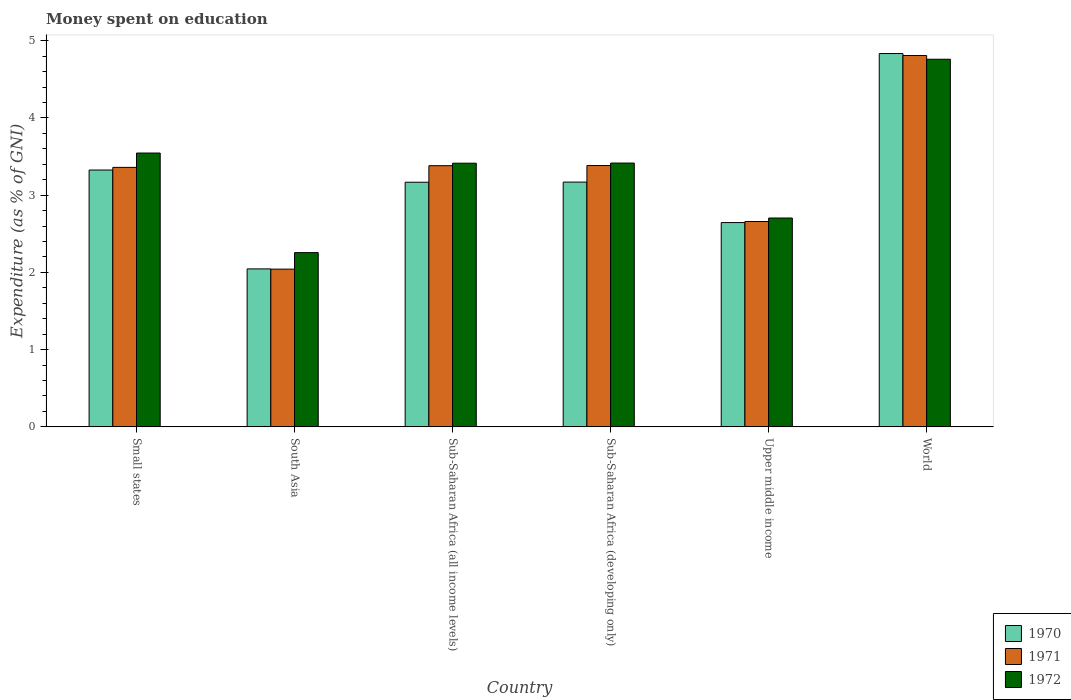How many groups of bars are there?
Offer a very short reply. 6. Are the number of bars on each tick of the X-axis equal?
Offer a terse response. Yes. How many bars are there on the 1st tick from the left?
Keep it short and to the point. 3. What is the label of the 1st group of bars from the left?
Your response must be concise. Small states. What is the amount of money spent on education in 1971 in Sub-Saharan Africa (all income levels)?
Offer a terse response. 3.38. Across all countries, what is the maximum amount of money spent on education in 1972?
Offer a very short reply. 4.76. Across all countries, what is the minimum amount of money spent on education in 1970?
Your answer should be compact. 2.05. In which country was the amount of money spent on education in 1971 maximum?
Give a very brief answer. World. In which country was the amount of money spent on education in 1970 minimum?
Offer a very short reply. South Asia. What is the total amount of money spent on education in 1970 in the graph?
Your answer should be compact. 19.19. What is the difference between the amount of money spent on education in 1972 in Small states and that in South Asia?
Your answer should be compact. 1.29. What is the difference between the amount of money spent on education in 1972 in South Asia and the amount of money spent on education in 1970 in World?
Provide a short and direct response. -2.58. What is the average amount of money spent on education in 1970 per country?
Keep it short and to the point. 3.2. What is the difference between the amount of money spent on education of/in 1970 and amount of money spent on education of/in 1971 in Upper middle income?
Provide a short and direct response. -0.01. What is the ratio of the amount of money spent on education in 1972 in Sub-Saharan Africa (developing only) to that in Upper middle income?
Provide a short and direct response. 1.26. Is the amount of money spent on education in 1971 in South Asia less than that in Sub-Saharan Africa (developing only)?
Ensure brevity in your answer.  Yes. What is the difference between the highest and the second highest amount of money spent on education in 1971?
Offer a very short reply. -0. What is the difference between the highest and the lowest amount of money spent on education in 1970?
Your answer should be compact. 2.79. In how many countries, is the amount of money spent on education in 1971 greater than the average amount of money spent on education in 1971 taken over all countries?
Your response must be concise. 4. Is the sum of the amount of money spent on education in 1970 in Sub-Saharan Africa (developing only) and Upper middle income greater than the maximum amount of money spent on education in 1971 across all countries?
Provide a short and direct response. Yes. What does the 3rd bar from the left in World represents?
Provide a short and direct response. 1972. What does the 2nd bar from the right in Upper middle income represents?
Offer a terse response. 1971. Is it the case that in every country, the sum of the amount of money spent on education in 1970 and amount of money spent on education in 1972 is greater than the amount of money spent on education in 1971?
Keep it short and to the point. Yes. How many bars are there?
Provide a succinct answer. 18. Are all the bars in the graph horizontal?
Your response must be concise. No. What is the difference between two consecutive major ticks on the Y-axis?
Your answer should be compact. 1. Are the values on the major ticks of Y-axis written in scientific E-notation?
Offer a terse response. No. Does the graph contain any zero values?
Offer a terse response. No. Where does the legend appear in the graph?
Offer a very short reply. Bottom right. How many legend labels are there?
Offer a very short reply. 3. What is the title of the graph?
Provide a short and direct response. Money spent on education. What is the label or title of the Y-axis?
Ensure brevity in your answer.  Expenditure (as % of GNI). What is the Expenditure (as % of GNI) of 1970 in Small states?
Give a very brief answer. 3.33. What is the Expenditure (as % of GNI) of 1971 in Small states?
Offer a very short reply. 3.36. What is the Expenditure (as % of GNI) of 1972 in Small states?
Your response must be concise. 3.55. What is the Expenditure (as % of GNI) of 1970 in South Asia?
Make the answer very short. 2.05. What is the Expenditure (as % of GNI) in 1971 in South Asia?
Provide a short and direct response. 2.04. What is the Expenditure (as % of GNI) of 1972 in South Asia?
Give a very brief answer. 2.26. What is the Expenditure (as % of GNI) in 1970 in Sub-Saharan Africa (all income levels)?
Keep it short and to the point. 3.17. What is the Expenditure (as % of GNI) in 1971 in Sub-Saharan Africa (all income levels)?
Your response must be concise. 3.38. What is the Expenditure (as % of GNI) in 1972 in Sub-Saharan Africa (all income levels)?
Ensure brevity in your answer.  3.41. What is the Expenditure (as % of GNI) of 1970 in Sub-Saharan Africa (developing only)?
Provide a succinct answer. 3.17. What is the Expenditure (as % of GNI) in 1971 in Sub-Saharan Africa (developing only)?
Your answer should be compact. 3.38. What is the Expenditure (as % of GNI) of 1972 in Sub-Saharan Africa (developing only)?
Your response must be concise. 3.42. What is the Expenditure (as % of GNI) in 1970 in Upper middle income?
Provide a short and direct response. 2.65. What is the Expenditure (as % of GNI) in 1971 in Upper middle income?
Offer a terse response. 2.66. What is the Expenditure (as % of GNI) in 1972 in Upper middle income?
Keep it short and to the point. 2.7. What is the Expenditure (as % of GNI) in 1970 in World?
Your answer should be very brief. 4.83. What is the Expenditure (as % of GNI) in 1971 in World?
Provide a short and direct response. 4.81. What is the Expenditure (as % of GNI) of 1972 in World?
Offer a very short reply. 4.76. Across all countries, what is the maximum Expenditure (as % of GNI) in 1970?
Give a very brief answer. 4.83. Across all countries, what is the maximum Expenditure (as % of GNI) of 1971?
Give a very brief answer. 4.81. Across all countries, what is the maximum Expenditure (as % of GNI) in 1972?
Provide a short and direct response. 4.76. Across all countries, what is the minimum Expenditure (as % of GNI) of 1970?
Keep it short and to the point. 2.05. Across all countries, what is the minimum Expenditure (as % of GNI) in 1971?
Provide a succinct answer. 2.04. Across all countries, what is the minimum Expenditure (as % of GNI) in 1972?
Ensure brevity in your answer.  2.26. What is the total Expenditure (as % of GNI) in 1970 in the graph?
Keep it short and to the point. 19.19. What is the total Expenditure (as % of GNI) in 1971 in the graph?
Keep it short and to the point. 19.64. What is the total Expenditure (as % of GNI) in 1972 in the graph?
Give a very brief answer. 20.1. What is the difference between the Expenditure (as % of GNI) in 1970 in Small states and that in South Asia?
Ensure brevity in your answer.  1.28. What is the difference between the Expenditure (as % of GNI) of 1971 in Small states and that in South Asia?
Make the answer very short. 1.32. What is the difference between the Expenditure (as % of GNI) of 1972 in Small states and that in South Asia?
Provide a succinct answer. 1.29. What is the difference between the Expenditure (as % of GNI) of 1970 in Small states and that in Sub-Saharan Africa (all income levels)?
Offer a very short reply. 0.16. What is the difference between the Expenditure (as % of GNI) of 1971 in Small states and that in Sub-Saharan Africa (all income levels)?
Your answer should be very brief. -0.02. What is the difference between the Expenditure (as % of GNI) of 1972 in Small states and that in Sub-Saharan Africa (all income levels)?
Provide a short and direct response. 0.13. What is the difference between the Expenditure (as % of GNI) in 1970 in Small states and that in Sub-Saharan Africa (developing only)?
Make the answer very short. 0.16. What is the difference between the Expenditure (as % of GNI) of 1971 in Small states and that in Sub-Saharan Africa (developing only)?
Provide a short and direct response. -0.02. What is the difference between the Expenditure (as % of GNI) of 1972 in Small states and that in Sub-Saharan Africa (developing only)?
Ensure brevity in your answer.  0.13. What is the difference between the Expenditure (as % of GNI) of 1970 in Small states and that in Upper middle income?
Provide a short and direct response. 0.68. What is the difference between the Expenditure (as % of GNI) of 1971 in Small states and that in Upper middle income?
Your answer should be compact. 0.7. What is the difference between the Expenditure (as % of GNI) in 1972 in Small states and that in Upper middle income?
Provide a succinct answer. 0.84. What is the difference between the Expenditure (as % of GNI) of 1970 in Small states and that in World?
Provide a succinct answer. -1.51. What is the difference between the Expenditure (as % of GNI) of 1971 in Small states and that in World?
Provide a short and direct response. -1.45. What is the difference between the Expenditure (as % of GNI) in 1972 in Small states and that in World?
Make the answer very short. -1.21. What is the difference between the Expenditure (as % of GNI) in 1970 in South Asia and that in Sub-Saharan Africa (all income levels)?
Your answer should be very brief. -1.12. What is the difference between the Expenditure (as % of GNI) of 1971 in South Asia and that in Sub-Saharan Africa (all income levels)?
Provide a short and direct response. -1.34. What is the difference between the Expenditure (as % of GNI) in 1972 in South Asia and that in Sub-Saharan Africa (all income levels)?
Keep it short and to the point. -1.16. What is the difference between the Expenditure (as % of GNI) in 1970 in South Asia and that in Sub-Saharan Africa (developing only)?
Give a very brief answer. -1.12. What is the difference between the Expenditure (as % of GNI) of 1971 in South Asia and that in Sub-Saharan Africa (developing only)?
Keep it short and to the point. -1.34. What is the difference between the Expenditure (as % of GNI) in 1972 in South Asia and that in Sub-Saharan Africa (developing only)?
Ensure brevity in your answer.  -1.16. What is the difference between the Expenditure (as % of GNI) of 1970 in South Asia and that in Upper middle income?
Your answer should be very brief. -0.6. What is the difference between the Expenditure (as % of GNI) in 1971 in South Asia and that in Upper middle income?
Keep it short and to the point. -0.62. What is the difference between the Expenditure (as % of GNI) in 1972 in South Asia and that in Upper middle income?
Provide a short and direct response. -0.45. What is the difference between the Expenditure (as % of GNI) in 1970 in South Asia and that in World?
Give a very brief answer. -2.79. What is the difference between the Expenditure (as % of GNI) in 1971 in South Asia and that in World?
Provide a succinct answer. -2.77. What is the difference between the Expenditure (as % of GNI) of 1972 in South Asia and that in World?
Ensure brevity in your answer.  -2.5. What is the difference between the Expenditure (as % of GNI) in 1970 in Sub-Saharan Africa (all income levels) and that in Sub-Saharan Africa (developing only)?
Your answer should be very brief. -0. What is the difference between the Expenditure (as % of GNI) of 1971 in Sub-Saharan Africa (all income levels) and that in Sub-Saharan Africa (developing only)?
Your response must be concise. -0. What is the difference between the Expenditure (as % of GNI) in 1972 in Sub-Saharan Africa (all income levels) and that in Sub-Saharan Africa (developing only)?
Provide a succinct answer. -0. What is the difference between the Expenditure (as % of GNI) of 1970 in Sub-Saharan Africa (all income levels) and that in Upper middle income?
Provide a succinct answer. 0.52. What is the difference between the Expenditure (as % of GNI) in 1971 in Sub-Saharan Africa (all income levels) and that in Upper middle income?
Offer a terse response. 0.72. What is the difference between the Expenditure (as % of GNI) in 1972 in Sub-Saharan Africa (all income levels) and that in Upper middle income?
Offer a terse response. 0.71. What is the difference between the Expenditure (as % of GNI) of 1970 in Sub-Saharan Africa (all income levels) and that in World?
Keep it short and to the point. -1.67. What is the difference between the Expenditure (as % of GNI) of 1971 in Sub-Saharan Africa (all income levels) and that in World?
Your answer should be compact. -1.43. What is the difference between the Expenditure (as % of GNI) in 1972 in Sub-Saharan Africa (all income levels) and that in World?
Provide a short and direct response. -1.35. What is the difference between the Expenditure (as % of GNI) in 1970 in Sub-Saharan Africa (developing only) and that in Upper middle income?
Provide a succinct answer. 0.52. What is the difference between the Expenditure (as % of GNI) in 1971 in Sub-Saharan Africa (developing only) and that in Upper middle income?
Keep it short and to the point. 0.72. What is the difference between the Expenditure (as % of GNI) in 1972 in Sub-Saharan Africa (developing only) and that in Upper middle income?
Provide a succinct answer. 0.71. What is the difference between the Expenditure (as % of GNI) in 1970 in Sub-Saharan Africa (developing only) and that in World?
Ensure brevity in your answer.  -1.66. What is the difference between the Expenditure (as % of GNI) of 1971 in Sub-Saharan Africa (developing only) and that in World?
Provide a succinct answer. -1.42. What is the difference between the Expenditure (as % of GNI) of 1972 in Sub-Saharan Africa (developing only) and that in World?
Keep it short and to the point. -1.34. What is the difference between the Expenditure (as % of GNI) of 1970 in Upper middle income and that in World?
Give a very brief answer. -2.19. What is the difference between the Expenditure (as % of GNI) in 1971 in Upper middle income and that in World?
Offer a terse response. -2.15. What is the difference between the Expenditure (as % of GNI) of 1972 in Upper middle income and that in World?
Give a very brief answer. -2.06. What is the difference between the Expenditure (as % of GNI) of 1970 in Small states and the Expenditure (as % of GNI) of 1971 in South Asia?
Make the answer very short. 1.28. What is the difference between the Expenditure (as % of GNI) of 1970 in Small states and the Expenditure (as % of GNI) of 1972 in South Asia?
Your answer should be very brief. 1.07. What is the difference between the Expenditure (as % of GNI) of 1971 in Small states and the Expenditure (as % of GNI) of 1972 in South Asia?
Keep it short and to the point. 1.1. What is the difference between the Expenditure (as % of GNI) in 1970 in Small states and the Expenditure (as % of GNI) in 1971 in Sub-Saharan Africa (all income levels)?
Your answer should be very brief. -0.06. What is the difference between the Expenditure (as % of GNI) of 1970 in Small states and the Expenditure (as % of GNI) of 1972 in Sub-Saharan Africa (all income levels)?
Give a very brief answer. -0.09. What is the difference between the Expenditure (as % of GNI) of 1971 in Small states and the Expenditure (as % of GNI) of 1972 in Sub-Saharan Africa (all income levels)?
Offer a very short reply. -0.05. What is the difference between the Expenditure (as % of GNI) in 1970 in Small states and the Expenditure (as % of GNI) in 1971 in Sub-Saharan Africa (developing only)?
Provide a succinct answer. -0.06. What is the difference between the Expenditure (as % of GNI) in 1970 in Small states and the Expenditure (as % of GNI) in 1972 in Sub-Saharan Africa (developing only)?
Offer a very short reply. -0.09. What is the difference between the Expenditure (as % of GNI) of 1971 in Small states and the Expenditure (as % of GNI) of 1972 in Sub-Saharan Africa (developing only)?
Ensure brevity in your answer.  -0.06. What is the difference between the Expenditure (as % of GNI) in 1970 in Small states and the Expenditure (as % of GNI) in 1971 in Upper middle income?
Give a very brief answer. 0.67. What is the difference between the Expenditure (as % of GNI) of 1970 in Small states and the Expenditure (as % of GNI) of 1972 in Upper middle income?
Your response must be concise. 0.62. What is the difference between the Expenditure (as % of GNI) of 1971 in Small states and the Expenditure (as % of GNI) of 1972 in Upper middle income?
Your response must be concise. 0.66. What is the difference between the Expenditure (as % of GNI) in 1970 in Small states and the Expenditure (as % of GNI) in 1971 in World?
Offer a very short reply. -1.48. What is the difference between the Expenditure (as % of GNI) of 1970 in Small states and the Expenditure (as % of GNI) of 1972 in World?
Your response must be concise. -1.43. What is the difference between the Expenditure (as % of GNI) of 1971 in Small states and the Expenditure (as % of GNI) of 1972 in World?
Keep it short and to the point. -1.4. What is the difference between the Expenditure (as % of GNI) of 1970 in South Asia and the Expenditure (as % of GNI) of 1971 in Sub-Saharan Africa (all income levels)?
Make the answer very short. -1.34. What is the difference between the Expenditure (as % of GNI) of 1970 in South Asia and the Expenditure (as % of GNI) of 1972 in Sub-Saharan Africa (all income levels)?
Provide a succinct answer. -1.37. What is the difference between the Expenditure (as % of GNI) of 1971 in South Asia and the Expenditure (as % of GNI) of 1972 in Sub-Saharan Africa (all income levels)?
Ensure brevity in your answer.  -1.37. What is the difference between the Expenditure (as % of GNI) in 1970 in South Asia and the Expenditure (as % of GNI) in 1971 in Sub-Saharan Africa (developing only)?
Ensure brevity in your answer.  -1.34. What is the difference between the Expenditure (as % of GNI) in 1970 in South Asia and the Expenditure (as % of GNI) in 1972 in Sub-Saharan Africa (developing only)?
Your answer should be very brief. -1.37. What is the difference between the Expenditure (as % of GNI) in 1971 in South Asia and the Expenditure (as % of GNI) in 1972 in Sub-Saharan Africa (developing only)?
Your response must be concise. -1.37. What is the difference between the Expenditure (as % of GNI) in 1970 in South Asia and the Expenditure (as % of GNI) in 1971 in Upper middle income?
Make the answer very short. -0.61. What is the difference between the Expenditure (as % of GNI) in 1970 in South Asia and the Expenditure (as % of GNI) in 1972 in Upper middle income?
Provide a succinct answer. -0.66. What is the difference between the Expenditure (as % of GNI) in 1971 in South Asia and the Expenditure (as % of GNI) in 1972 in Upper middle income?
Keep it short and to the point. -0.66. What is the difference between the Expenditure (as % of GNI) in 1970 in South Asia and the Expenditure (as % of GNI) in 1971 in World?
Your answer should be very brief. -2.76. What is the difference between the Expenditure (as % of GNI) of 1970 in South Asia and the Expenditure (as % of GNI) of 1972 in World?
Your answer should be very brief. -2.71. What is the difference between the Expenditure (as % of GNI) of 1971 in South Asia and the Expenditure (as % of GNI) of 1972 in World?
Your answer should be very brief. -2.72. What is the difference between the Expenditure (as % of GNI) in 1970 in Sub-Saharan Africa (all income levels) and the Expenditure (as % of GNI) in 1971 in Sub-Saharan Africa (developing only)?
Make the answer very short. -0.22. What is the difference between the Expenditure (as % of GNI) of 1970 in Sub-Saharan Africa (all income levels) and the Expenditure (as % of GNI) of 1972 in Sub-Saharan Africa (developing only)?
Ensure brevity in your answer.  -0.25. What is the difference between the Expenditure (as % of GNI) in 1971 in Sub-Saharan Africa (all income levels) and the Expenditure (as % of GNI) in 1972 in Sub-Saharan Africa (developing only)?
Ensure brevity in your answer.  -0.03. What is the difference between the Expenditure (as % of GNI) of 1970 in Sub-Saharan Africa (all income levels) and the Expenditure (as % of GNI) of 1971 in Upper middle income?
Offer a very short reply. 0.51. What is the difference between the Expenditure (as % of GNI) of 1970 in Sub-Saharan Africa (all income levels) and the Expenditure (as % of GNI) of 1972 in Upper middle income?
Provide a short and direct response. 0.46. What is the difference between the Expenditure (as % of GNI) of 1971 in Sub-Saharan Africa (all income levels) and the Expenditure (as % of GNI) of 1972 in Upper middle income?
Ensure brevity in your answer.  0.68. What is the difference between the Expenditure (as % of GNI) in 1970 in Sub-Saharan Africa (all income levels) and the Expenditure (as % of GNI) in 1971 in World?
Offer a terse response. -1.64. What is the difference between the Expenditure (as % of GNI) in 1970 in Sub-Saharan Africa (all income levels) and the Expenditure (as % of GNI) in 1972 in World?
Give a very brief answer. -1.59. What is the difference between the Expenditure (as % of GNI) of 1971 in Sub-Saharan Africa (all income levels) and the Expenditure (as % of GNI) of 1972 in World?
Offer a terse response. -1.38. What is the difference between the Expenditure (as % of GNI) in 1970 in Sub-Saharan Africa (developing only) and the Expenditure (as % of GNI) in 1971 in Upper middle income?
Ensure brevity in your answer.  0.51. What is the difference between the Expenditure (as % of GNI) of 1970 in Sub-Saharan Africa (developing only) and the Expenditure (as % of GNI) of 1972 in Upper middle income?
Provide a succinct answer. 0.47. What is the difference between the Expenditure (as % of GNI) of 1971 in Sub-Saharan Africa (developing only) and the Expenditure (as % of GNI) of 1972 in Upper middle income?
Make the answer very short. 0.68. What is the difference between the Expenditure (as % of GNI) in 1970 in Sub-Saharan Africa (developing only) and the Expenditure (as % of GNI) in 1971 in World?
Provide a succinct answer. -1.64. What is the difference between the Expenditure (as % of GNI) of 1970 in Sub-Saharan Africa (developing only) and the Expenditure (as % of GNI) of 1972 in World?
Offer a very short reply. -1.59. What is the difference between the Expenditure (as % of GNI) in 1971 in Sub-Saharan Africa (developing only) and the Expenditure (as % of GNI) in 1972 in World?
Give a very brief answer. -1.38. What is the difference between the Expenditure (as % of GNI) in 1970 in Upper middle income and the Expenditure (as % of GNI) in 1971 in World?
Provide a short and direct response. -2.16. What is the difference between the Expenditure (as % of GNI) in 1970 in Upper middle income and the Expenditure (as % of GNI) in 1972 in World?
Your answer should be very brief. -2.12. What is the difference between the Expenditure (as % of GNI) in 1971 in Upper middle income and the Expenditure (as % of GNI) in 1972 in World?
Your answer should be very brief. -2.1. What is the average Expenditure (as % of GNI) of 1970 per country?
Provide a succinct answer. 3.2. What is the average Expenditure (as % of GNI) of 1971 per country?
Provide a short and direct response. 3.27. What is the average Expenditure (as % of GNI) in 1972 per country?
Give a very brief answer. 3.35. What is the difference between the Expenditure (as % of GNI) in 1970 and Expenditure (as % of GNI) in 1971 in Small states?
Provide a succinct answer. -0.03. What is the difference between the Expenditure (as % of GNI) of 1970 and Expenditure (as % of GNI) of 1972 in Small states?
Provide a succinct answer. -0.22. What is the difference between the Expenditure (as % of GNI) of 1971 and Expenditure (as % of GNI) of 1972 in Small states?
Your answer should be very brief. -0.19. What is the difference between the Expenditure (as % of GNI) of 1970 and Expenditure (as % of GNI) of 1971 in South Asia?
Make the answer very short. 0. What is the difference between the Expenditure (as % of GNI) of 1970 and Expenditure (as % of GNI) of 1972 in South Asia?
Your response must be concise. -0.21. What is the difference between the Expenditure (as % of GNI) of 1971 and Expenditure (as % of GNI) of 1972 in South Asia?
Your answer should be compact. -0.21. What is the difference between the Expenditure (as % of GNI) of 1970 and Expenditure (as % of GNI) of 1971 in Sub-Saharan Africa (all income levels)?
Make the answer very short. -0.21. What is the difference between the Expenditure (as % of GNI) in 1970 and Expenditure (as % of GNI) in 1972 in Sub-Saharan Africa (all income levels)?
Give a very brief answer. -0.25. What is the difference between the Expenditure (as % of GNI) of 1971 and Expenditure (as % of GNI) of 1972 in Sub-Saharan Africa (all income levels)?
Your response must be concise. -0.03. What is the difference between the Expenditure (as % of GNI) in 1970 and Expenditure (as % of GNI) in 1971 in Sub-Saharan Africa (developing only)?
Make the answer very short. -0.21. What is the difference between the Expenditure (as % of GNI) in 1970 and Expenditure (as % of GNI) in 1972 in Sub-Saharan Africa (developing only)?
Give a very brief answer. -0.25. What is the difference between the Expenditure (as % of GNI) of 1971 and Expenditure (as % of GNI) of 1972 in Sub-Saharan Africa (developing only)?
Provide a short and direct response. -0.03. What is the difference between the Expenditure (as % of GNI) of 1970 and Expenditure (as % of GNI) of 1971 in Upper middle income?
Offer a terse response. -0.01. What is the difference between the Expenditure (as % of GNI) in 1970 and Expenditure (as % of GNI) in 1972 in Upper middle income?
Ensure brevity in your answer.  -0.06. What is the difference between the Expenditure (as % of GNI) in 1971 and Expenditure (as % of GNI) in 1972 in Upper middle income?
Your answer should be very brief. -0.05. What is the difference between the Expenditure (as % of GNI) in 1970 and Expenditure (as % of GNI) in 1971 in World?
Provide a succinct answer. 0.03. What is the difference between the Expenditure (as % of GNI) of 1970 and Expenditure (as % of GNI) of 1972 in World?
Make the answer very short. 0.07. What is the difference between the Expenditure (as % of GNI) of 1971 and Expenditure (as % of GNI) of 1972 in World?
Offer a very short reply. 0.05. What is the ratio of the Expenditure (as % of GNI) of 1970 in Small states to that in South Asia?
Offer a terse response. 1.63. What is the ratio of the Expenditure (as % of GNI) of 1971 in Small states to that in South Asia?
Give a very brief answer. 1.65. What is the ratio of the Expenditure (as % of GNI) of 1972 in Small states to that in South Asia?
Your answer should be compact. 1.57. What is the ratio of the Expenditure (as % of GNI) in 1970 in Small states to that in Sub-Saharan Africa (all income levels)?
Offer a terse response. 1.05. What is the ratio of the Expenditure (as % of GNI) of 1971 in Small states to that in Sub-Saharan Africa (all income levels)?
Your answer should be compact. 0.99. What is the ratio of the Expenditure (as % of GNI) of 1970 in Small states to that in Sub-Saharan Africa (developing only)?
Keep it short and to the point. 1.05. What is the ratio of the Expenditure (as % of GNI) in 1972 in Small states to that in Sub-Saharan Africa (developing only)?
Ensure brevity in your answer.  1.04. What is the ratio of the Expenditure (as % of GNI) in 1970 in Small states to that in Upper middle income?
Your answer should be compact. 1.26. What is the ratio of the Expenditure (as % of GNI) in 1971 in Small states to that in Upper middle income?
Offer a very short reply. 1.26. What is the ratio of the Expenditure (as % of GNI) of 1972 in Small states to that in Upper middle income?
Your answer should be compact. 1.31. What is the ratio of the Expenditure (as % of GNI) of 1970 in Small states to that in World?
Give a very brief answer. 0.69. What is the ratio of the Expenditure (as % of GNI) in 1971 in Small states to that in World?
Ensure brevity in your answer.  0.7. What is the ratio of the Expenditure (as % of GNI) of 1972 in Small states to that in World?
Your answer should be compact. 0.74. What is the ratio of the Expenditure (as % of GNI) in 1970 in South Asia to that in Sub-Saharan Africa (all income levels)?
Provide a short and direct response. 0.65. What is the ratio of the Expenditure (as % of GNI) of 1971 in South Asia to that in Sub-Saharan Africa (all income levels)?
Keep it short and to the point. 0.6. What is the ratio of the Expenditure (as % of GNI) in 1972 in South Asia to that in Sub-Saharan Africa (all income levels)?
Your response must be concise. 0.66. What is the ratio of the Expenditure (as % of GNI) in 1970 in South Asia to that in Sub-Saharan Africa (developing only)?
Give a very brief answer. 0.65. What is the ratio of the Expenditure (as % of GNI) of 1971 in South Asia to that in Sub-Saharan Africa (developing only)?
Your response must be concise. 0.6. What is the ratio of the Expenditure (as % of GNI) of 1972 in South Asia to that in Sub-Saharan Africa (developing only)?
Your answer should be compact. 0.66. What is the ratio of the Expenditure (as % of GNI) in 1970 in South Asia to that in Upper middle income?
Give a very brief answer. 0.77. What is the ratio of the Expenditure (as % of GNI) in 1971 in South Asia to that in Upper middle income?
Offer a very short reply. 0.77. What is the ratio of the Expenditure (as % of GNI) of 1972 in South Asia to that in Upper middle income?
Offer a very short reply. 0.83. What is the ratio of the Expenditure (as % of GNI) of 1970 in South Asia to that in World?
Offer a very short reply. 0.42. What is the ratio of the Expenditure (as % of GNI) of 1971 in South Asia to that in World?
Keep it short and to the point. 0.42. What is the ratio of the Expenditure (as % of GNI) in 1972 in South Asia to that in World?
Ensure brevity in your answer.  0.47. What is the ratio of the Expenditure (as % of GNI) in 1971 in Sub-Saharan Africa (all income levels) to that in Sub-Saharan Africa (developing only)?
Your answer should be compact. 1. What is the ratio of the Expenditure (as % of GNI) in 1972 in Sub-Saharan Africa (all income levels) to that in Sub-Saharan Africa (developing only)?
Offer a very short reply. 1. What is the ratio of the Expenditure (as % of GNI) in 1970 in Sub-Saharan Africa (all income levels) to that in Upper middle income?
Make the answer very short. 1.2. What is the ratio of the Expenditure (as % of GNI) in 1971 in Sub-Saharan Africa (all income levels) to that in Upper middle income?
Keep it short and to the point. 1.27. What is the ratio of the Expenditure (as % of GNI) in 1972 in Sub-Saharan Africa (all income levels) to that in Upper middle income?
Your answer should be very brief. 1.26. What is the ratio of the Expenditure (as % of GNI) of 1970 in Sub-Saharan Africa (all income levels) to that in World?
Make the answer very short. 0.66. What is the ratio of the Expenditure (as % of GNI) of 1971 in Sub-Saharan Africa (all income levels) to that in World?
Give a very brief answer. 0.7. What is the ratio of the Expenditure (as % of GNI) of 1972 in Sub-Saharan Africa (all income levels) to that in World?
Your answer should be compact. 0.72. What is the ratio of the Expenditure (as % of GNI) of 1970 in Sub-Saharan Africa (developing only) to that in Upper middle income?
Keep it short and to the point. 1.2. What is the ratio of the Expenditure (as % of GNI) of 1971 in Sub-Saharan Africa (developing only) to that in Upper middle income?
Offer a very short reply. 1.27. What is the ratio of the Expenditure (as % of GNI) in 1972 in Sub-Saharan Africa (developing only) to that in Upper middle income?
Offer a very short reply. 1.26. What is the ratio of the Expenditure (as % of GNI) of 1970 in Sub-Saharan Africa (developing only) to that in World?
Make the answer very short. 0.66. What is the ratio of the Expenditure (as % of GNI) in 1971 in Sub-Saharan Africa (developing only) to that in World?
Give a very brief answer. 0.7. What is the ratio of the Expenditure (as % of GNI) of 1972 in Sub-Saharan Africa (developing only) to that in World?
Your response must be concise. 0.72. What is the ratio of the Expenditure (as % of GNI) in 1970 in Upper middle income to that in World?
Offer a terse response. 0.55. What is the ratio of the Expenditure (as % of GNI) of 1971 in Upper middle income to that in World?
Your response must be concise. 0.55. What is the ratio of the Expenditure (as % of GNI) of 1972 in Upper middle income to that in World?
Your answer should be very brief. 0.57. What is the difference between the highest and the second highest Expenditure (as % of GNI) of 1970?
Make the answer very short. 1.51. What is the difference between the highest and the second highest Expenditure (as % of GNI) in 1971?
Keep it short and to the point. 1.42. What is the difference between the highest and the second highest Expenditure (as % of GNI) in 1972?
Offer a terse response. 1.21. What is the difference between the highest and the lowest Expenditure (as % of GNI) of 1970?
Your answer should be compact. 2.79. What is the difference between the highest and the lowest Expenditure (as % of GNI) in 1971?
Keep it short and to the point. 2.77. What is the difference between the highest and the lowest Expenditure (as % of GNI) of 1972?
Ensure brevity in your answer.  2.5. 